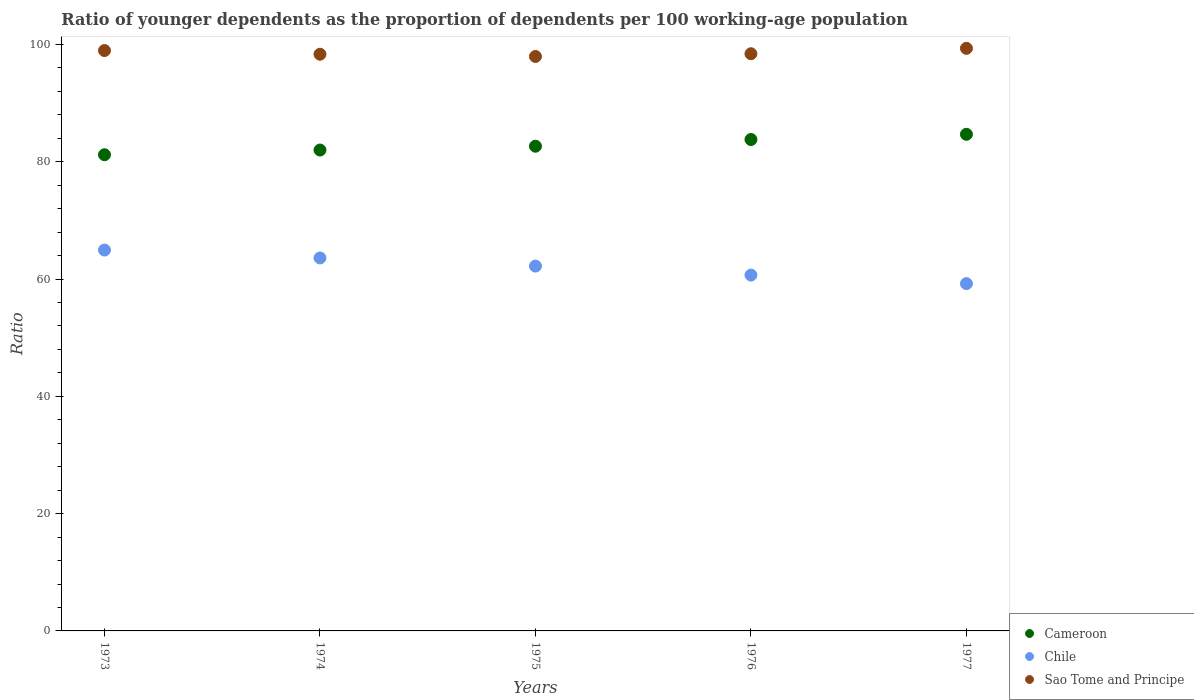How many different coloured dotlines are there?
Offer a very short reply. 3. Is the number of dotlines equal to the number of legend labels?
Provide a succinct answer. Yes. What is the age dependency ratio(young) in Sao Tome and Principe in 1974?
Offer a terse response. 98.34. Across all years, what is the maximum age dependency ratio(young) in Sao Tome and Principe?
Ensure brevity in your answer.  99.34. Across all years, what is the minimum age dependency ratio(young) in Chile?
Provide a succinct answer. 59.22. In which year was the age dependency ratio(young) in Sao Tome and Principe maximum?
Your response must be concise. 1977. In which year was the age dependency ratio(young) in Chile minimum?
Your answer should be very brief. 1977. What is the total age dependency ratio(young) in Chile in the graph?
Your response must be concise. 310.66. What is the difference between the age dependency ratio(young) in Chile in 1975 and that in 1976?
Make the answer very short. 1.53. What is the difference between the age dependency ratio(young) in Chile in 1973 and the age dependency ratio(young) in Sao Tome and Principe in 1975?
Provide a succinct answer. -33.01. What is the average age dependency ratio(young) in Sao Tome and Principe per year?
Offer a terse response. 98.61. In the year 1977, what is the difference between the age dependency ratio(young) in Sao Tome and Principe and age dependency ratio(young) in Chile?
Give a very brief answer. 40.12. What is the ratio of the age dependency ratio(young) in Chile in 1976 to that in 1977?
Your answer should be very brief. 1.02. Is the age dependency ratio(young) in Cameroon in 1974 less than that in 1975?
Offer a very short reply. Yes. Is the difference between the age dependency ratio(young) in Sao Tome and Principe in 1973 and 1974 greater than the difference between the age dependency ratio(young) in Chile in 1973 and 1974?
Provide a short and direct response. No. What is the difference between the highest and the second highest age dependency ratio(young) in Sao Tome and Principe?
Offer a terse response. 0.38. What is the difference between the highest and the lowest age dependency ratio(young) in Chile?
Make the answer very short. 5.72. Is it the case that in every year, the sum of the age dependency ratio(young) in Sao Tome and Principe and age dependency ratio(young) in Chile  is greater than the age dependency ratio(young) in Cameroon?
Ensure brevity in your answer.  Yes. Is the age dependency ratio(young) in Sao Tome and Principe strictly greater than the age dependency ratio(young) in Chile over the years?
Offer a very short reply. Yes. How many years are there in the graph?
Provide a succinct answer. 5. Are the values on the major ticks of Y-axis written in scientific E-notation?
Offer a very short reply. No. Does the graph contain grids?
Provide a succinct answer. No. How many legend labels are there?
Offer a terse response. 3. How are the legend labels stacked?
Ensure brevity in your answer.  Vertical. What is the title of the graph?
Ensure brevity in your answer.  Ratio of younger dependents as the proportion of dependents per 100 working-age population. Does "Norway" appear as one of the legend labels in the graph?
Make the answer very short. No. What is the label or title of the X-axis?
Your response must be concise. Years. What is the label or title of the Y-axis?
Your answer should be very brief. Ratio. What is the Ratio in Cameroon in 1973?
Provide a succinct answer. 81.2. What is the Ratio of Chile in 1973?
Offer a very short reply. 64.95. What is the Ratio in Sao Tome and Principe in 1973?
Offer a very short reply. 98.97. What is the Ratio in Cameroon in 1974?
Ensure brevity in your answer.  82. What is the Ratio in Chile in 1974?
Ensure brevity in your answer.  63.6. What is the Ratio in Sao Tome and Principe in 1974?
Provide a succinct answer. 98.34. What is the Ratio in Cameroon in 1975?
Ensure brevity in your answer.  82.65. What is the Ratio in Chile in 1975?
Give a very brief answer. 62.21. What is the Ratio in Sao Tome and Principe in 1975?
Your answer should be compact. 97.96. What is the Ratio of Cameroon in 1976?
Offer a very short reply. 83.8. What is the Ratio in Chile in 1976?
Ensure brevity in your answer.  60.68. What is the Ratio of Sao Tome and Principe in 1976?
Your response must be concise. 98.42. What is the Ratio of Cameroon in 1977?
Provide a short and direct response. 84.69. What is the Ratio of Chile in 1977?
Your answer should be very brief. 59.22. What is the Ratio of Sao Tome and Principe in 1977?
Your response must be concise. 99.34. Across all years, what is the maximum Ratio in Cameroon?
Offer a very short reply. 84.69. Across all years, what is the maximum Ratio of Chile?
Ensure brevity in your answer.  64.95. Across all years, what is the maximum Ratio in Sao Tome and Principe?
Your response must be concise. 99.34. Across all years, what is the minimum Ratio in Cameroon?
Ensure brevity in your answer.  81.2. Across all years, what is the minimum Ratio in Chile?
Offer a very short reply. 59.22. Across all years, what is the minimum Ratio in Sao Tome and Principe?
Your response must be concise. 97.96. What is the total Ratio of Cameroon in the graph?
Provide a short and direct response. 414.33. What is the total Ratio in Chile in the graph?
Offer a very short reply. 310.66. What is the total Ratio in Sao Tome and Principe in the graph?
Offer a terse response. 493.03. What is the difference between the Ratio of Cameroon in 1973 and that in 1974?
Offer a very short reply. -0.8. What is the difference between the Ratio of Chile in 1973 and that in 1974?
Your answer should be very brief. 1.35. What is the difference between the Ratio of Sao Tome and Principe in 1973 and that in 1974?
Give a very brief answer. 0.63. What is the difference between the Ratio of Cameroon in 1973 and that in 1975?
Your answer should be very brief. -1.46. What is the difference between the Ratio of Chile in 1973 and that in 1975?
Offer a terse response. 2.73. What is the difference between the Ratio in Sao Tome and Principe in 1973 and that in 1975?
Provide a short and direct response. 1.01. What is the difference between the Ratio of Cameroon in 1973 and that in 1976?
Your answer should be compact. -2.6. What is the difference between the Ratio in Chile in 1973 and that in 1976?
Ensure brevity in your answer.  4.27. What is the difference between the Ratio of Sao Tome and Principe in 1973 and that in 1976?
Offer a terse response. 0.54. What is the difference between the Ratio of Cameroon in 1973 and that in 1977?
Keep it short and to the point. -3.49. What is the difference between the Ratio in Chile in 1973 and that in 1977?
Offer a very short reply. 5.72. What is the difference between the Ratio of Sao Tome and Principe in 1973 and that in 1977?
Provide a short and direct response. -0.38. What is the difference between the Ratio in Cameroon in 1974 and that in 1975?
Your answer should be very brief. -0.65. What is the difference between the Ratio of Chile in 1974 and that in 1975?
Your response must be concise. 1.39. What is the difference between the Ratio of Sao Tome and Principe in 1974 and that in 1975?
Provide a short and direct response. 0.38. What is the difference between the Ratio of Cameroon in 1974 and that in 1976?
Offer a terse response. -1.8. What is the difference between the Ratio of Chile in 1974 and that in 1976?
Give a very brief answer. 2.92. What is the difference between the Ratio in Sao Tome and Principe in 1974 and that in 1976?
Make the answer very short. -0.08. What is the difference between the Ratio of Cameroon in 1974 and that in 1977?
Make the answer very short. -2.69. What is the difference between the Ratio in Chile in 1974 and that in 1977?
Provide a succinct answer. 4.38. What is the difference between the Ratio of Sao Tome and Principe in 1974 and that in 1977?
Ensure brevity in your answer.  -1. What is the difference between the Ratio of Cameroon in 1975 and that in 1976?
Make the answer very short. -1.14. What is the difference between the Ratio in Chile in 1975 and that in 1976?
Your answer should be very brief. 1.53. What is the difference between the Ratio of Sao Tome and Principe in 1975 and that in 1976?
Make the answer very short. -0.47. What is the difference between the Ratio of Cameroon in 1975 and that in 1977?
Offer a terse response. -2.03. What is the difference between the Ratio in Chile in 1975 and that in 1977?
Make the answer very short. 2.99. What is the difference between the Ratio in Sao Tome and Principe in 1975 and that in 1977?
Your response must be concise. -1.39. What is the difference between the Ratio in Cameroon in 1976 and that in 1977?
Make the answer very short. -0.89. What is the difference between the Ratio in Chile in 1976 and that in 1977?
Your response must be concise. 1.46. What is the difference between the Ratio of Sao Tome and Principe in 1976 and that in 1977?
Provide a short and direct response. -0.92. What is the difference between the Ratio in Cameroon in 1973 and the Ratio in Chile in 1974?
Offer a terse response. 17.6. What is the difference between the Ratio of Cameroon in 1973 and the Ratio of Sao Tome and Principe in 1974?
Ensure brevity in your answer.  -17.14. What is the difference between the Ratio in Chile in 1973 and the Ratio in Sao Tome and Principe in 1974?
Provide a short and direct response. -33.39. What is the difference between the Ratio in Cameroon in 1973 and the Ratio in Chile in 1975?
Your answer should be very brief. 18.98. What is the difference between the Ratio in Cameroon in 1973 and the Ratio in Sao Tome and Principe in 1975?
Offer a terse response. -16.76. What is the difference between the Ratio in Chile in 1973 and the Ratio in Sao Tome and Principe in 1975?
Offer a very short reply. -33.01. What is the difference between the Ratio in Cameroon in 1973 and the Ratio in Chile in 1976?
Offer a terse response. 20.52. What is the difference between the Ratio in Cameroon in 1973 and the Ratio in Sao Tome and Principe in 1976?
Offer a very short reply. -17.22. What is the difference between the Ratio of Chile in 1973 and the Ratio of Sao Tome and Principe in 1976?
Offer a very short reply. -33.48. What is the difference between the Ratio of Cameroon in 1973 and the Ratio of Chile in 1977?
Keep it short and to the point. 21.98. What is the difference between the Ratio of Cameroon in 1973 and the Ratio of Sao Tome and Principe in 1977?
Make the answer very short. -18.14. What is the difference between the Ratio of Chile in 1973 and the Ratio of Sao Tome and Principe in 1977?
Keep it short and to the point. -34.4. What is the difference between the Ratio of Cameroon in 1974 and the Ratio of Chile in 1975?
Your response must be concise. 19.79. What is the difference between the Ratio of Cameroon in 1974 and the Ratio of Sao Tome and Principe in 1975?
Make the answer very short. -15.96. What is the difference between the Ratio of Chile in 1974 and the Ratio of Sao Tome and Principe in 1975?
Offer a very short reply. -34.36. What is the difference between the Ratio of Cameroon in 1974 and the Ratio of Chile in 1976?
Your answer should be very brief. 21.32. What is the difference between the Ratio of Cameroon in 1974 and the Ratio of Sao Tome and Principe in 1976?
Provide a short and direct response. -16.42. What is the difference between the Ratio in Chile in 1974 and the Ratio in Sao Tome and Principe in 1976?
Your answer should be compact. -34.82. What is the difference between the Ratio in Cameroon in 1974 and the Ratio in Chile in 1977?
Make the answer very short. 22.78. What is the difference between the Ratio in Cameroon in 1974 and the Ratio in Sao Tome and Principe in 1977?
Provide a short and direct response. -17.34. What is the difference between the Ratio of Chile in 1974 and the Ratio of Sao Tome and Principe in 1977?
Give a very brief answer. -35.74. What is the difference between the Ratio in Cameroon in 1975 and the Ratio in Chile in 1976?
Your response must be concise. 21.97. What is the difference between the Ratio of Cameroon in 1975 and the Ratio of Sao Tome and Principe in 1976?
Offer a terse response. -15.77. What is the difference between the Ratio in Chile in 1975 and the Ratio in Sao Tome and Principe in 1976?
Your answer should be very brief. -36.21. What is the difference between the Ratio in Cameroon in 1975 and the Ratio in Chile in 1977?
Your answer should be very brief. 23.43. What is the difference between the Ratio of Cameroon in 1975 and the Ratio of Sao Tome and Principe in 1977?
Give a very brief answer. -16.69. What is the difference between the Ratio of Chile in 1975 and the Ratio of Sao Tome and Principe in 1977?
Provide a short and direct response. -37.13. What is the difference between the Ratio of Cameroon in 1976 and the Ratio of Chile in 1977?
Offer a very short reply. 24.57. What is the difference between the Ratio in Cameroon in 1976 and the Ratio in Sao Tome and Principe in 1977?
Provide a short and direct response. -15.54. What is the difference between the Ratio in Chile in 1976 and the Ratio in Sao Tome and Principe in 1977?
Your answer should be very brief. -38.66. What is the average Ratio of Cameroon per year?
Keep it short and to the point. 82.87. What is the average Ratio in Chile per year?
Make the answer very short. 62.13. What is the average Ratio of Sao Tome and Principe per year?
Keep it short and to the point. 98.61. In the year 1973, what is the difference between the Ratio in Cameroon and Ratio in Chile?
Give a very brief answer. 16.25. In the year 1973, what is the difference between the Ratio in Cameroon and Ratio in Sao Tome and Principe?
Keep it short and to the point. -17.77. In the year 1973, what is the difference between the Ratio of Chile and Ratio of Sao Tome and Principe?
Offer a terse response. -34.02. In the year 1974, what is the difference between the Ratio in Cameroon and Ratio in Chile?
Your answer should be very brief. 18.4. In the year 1974, what is the difference between the Ratio in Cameroon and Ratio in Sao Tome and Principe?
Your answer should be compact. -16.34. In the year 1974, what is the difference between the Ratio in Chile and Ratio in Sao Tome and Principe?
Your response must be concise. -34.74. In the year 1975, what is the difference between the Ratio of Cameroon and Ratio of Chile?
Provide a succinct answer. 20.44. In the year 1975, what is the difference between the Ratio of Cameroon and Ratio of Sao Tome and Principe?
Offer a very short reply. -15.3. In the year 1975, what is the difference between the Ratio of Chile and Ratio of Sao Tome and Principe?
Provide a short and direct response. -35.74. In the year 1976, what is the difference between the Ratio in Cameroon and Ratio in Chile?
Your answer should be compact. 23.12. In the year 1976, what is the difference between the Ratio in Cameroon and Ratio in Sao Tome and Principe?
Your response must be concise. -14.63. In the year 1976, what is the difference between the Ratio in Chile and Ratio in Sao Tome and Principe?
Your answer should be compact. -37.74. In the year 1977, what is the difference between the Ratio of Cameroon and Ratio of Chile?
Ensure brevity in your answer.  25.46. In the year 1977, what is the difference between the Ratio in Cameroon and Ratio in Sao Tome and Principe?
Your response must be concise. -14.66. In the year 1977, what is the difference between the Ratio in Chile and Ratio in Sao Tome and Principe?
Offer a very short reply. -40.12. What is the ratio of the Ratio in Cameroon in 1973 to that in 1974?
Ensure brevity in your answer.  0.99. What is the ratio of the Ratio of Chile in 1973 to that in 1974?
Offer a very short reply. 1.02. What is the ratio of the Ratio in Sao Tome and Principe in 1973 to that in 1974?
Ensure brevity in your answer.  1.01. What is the ratio of the Ratio of Cameroon in 1973 to that in 1975?
Provide a succinct answer. 0.98. What is the ratio of the Ratio in Chile in 1973 to that in 1975?
Your answer should be very brief. 1.04. What is the ratio of the Ratio of Sao Tome and Principe in 1973 to that in 1975?
Keep it short and to the point. 1.01. What is the ratio of the Ratio of Chile in 1973 to that in 1976?
Offer a terse response. 1.07. What is the ratio of the Ratio in Sao Tome and Principe in 1973 to that in 1976?
Provide a succinct answer. 1.01. What is the ratio of the Ratio in Cameroon in 1973 to that in 1977?
Keep it short and to the point. 0.96. What is the ratio of the Ratio of Chile in 1973 to that in 1977?
Ensure brevity in your answer.  1.1. What is the ratio of the Ratio in Sao Tome and Principe in 1973 to that in 1977?
Provide a short and direct response. 1. What is the ratio of the Ratio in Cameroon in 1974 to that in 1975?
Offer a very short reply. 0.99. What is the ratio of the Ratio of Chile in 1974 to that in 1975?
Offer a terse response. 1.02. What is the ratio of the Ratio in Sao Tome and Principe in 1974 to that in 1975?
Your response must be concise. 1. What is the ratio of the Ratio in Cameroon in 1974 to that in 1976?
Your answer should be very brief. 0.98. What is the ratio of the Ratio of Chile in 1974 to that in 1976?
Make the answer very short. 1.05. What is the ratio of the Ratio of Cameroon in 1974 to that in 1977?
Offer a terse response. 0.97. What is the ratio of the Ratio of Chile in 1974 to that in 1977?
Provide a short and direct response. 1.07. What is the ratio of the Ratio of Sao Tome and Principe in 1974 to that in 1977?
Keep it short and to the point. 0.99. What is the ratio of the Ratio in Cameroon in 1975 to that in 1976?
Give a very brief answer. 0.99. What is the ratio of the Ratio of Chile in 1975 to that in 1976?
Your answer should be very brief. 1.03. What is the ratio of the Ratio in Sao Tome and Principe in 1975 to that in 1976?
Provide a succinct answer. 1. What is the ratio of the Ratio of Cameroon in 1975 to that in 1977?
Give a very brief answer. 0.98. What is the ratio of the Ratio of Chile in 1975 to that in 1977?
Give a very brief answer. 1.05. What is the ratio of the Ratio in Sao Tome and Principe in 1975 to that in 1977?
Your response must be concise. 0.99. What is the ratio of the Ratio of Chile in 1976 to that in 1977?
Your answer should be compact. 1.02. What is the difference between the highest and the second highest Ratio of Cameroon?
Offer a very short reply. 0.89. What is the difference between the highest and the second highest Ratio of Chile?
Offer a very short reply. 1.35. What is the difference between the highest and the second highest Ratio in Sao Tome and Principe?
Provide a short and direct response. 0.38. What is the difference between the highest and the lowest Ratio of Cameroon?
Offer a very short reply. 3.49. What is the difference between the highest and the lowest Ratio of Chile?
Offer a terse response. 5.72. What is the difference between the highest and the lowest Ratio in Sao Tome and Principe?
Ensure brevity in your answer.  1.39. 